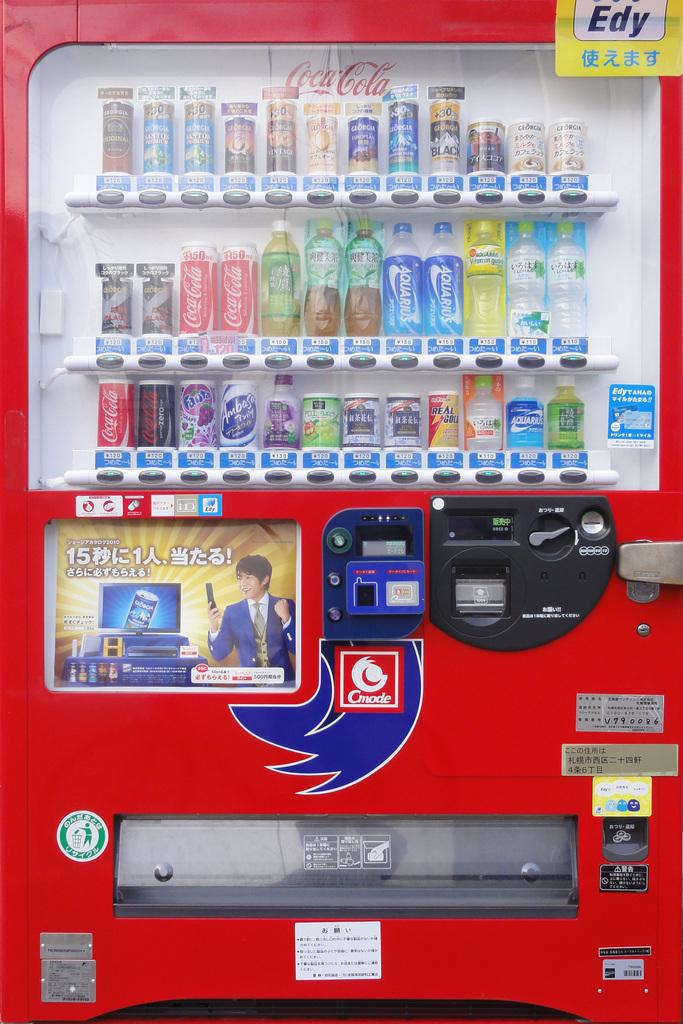<image>
Describe the image concisely. a red ending machine with several coca cola products 